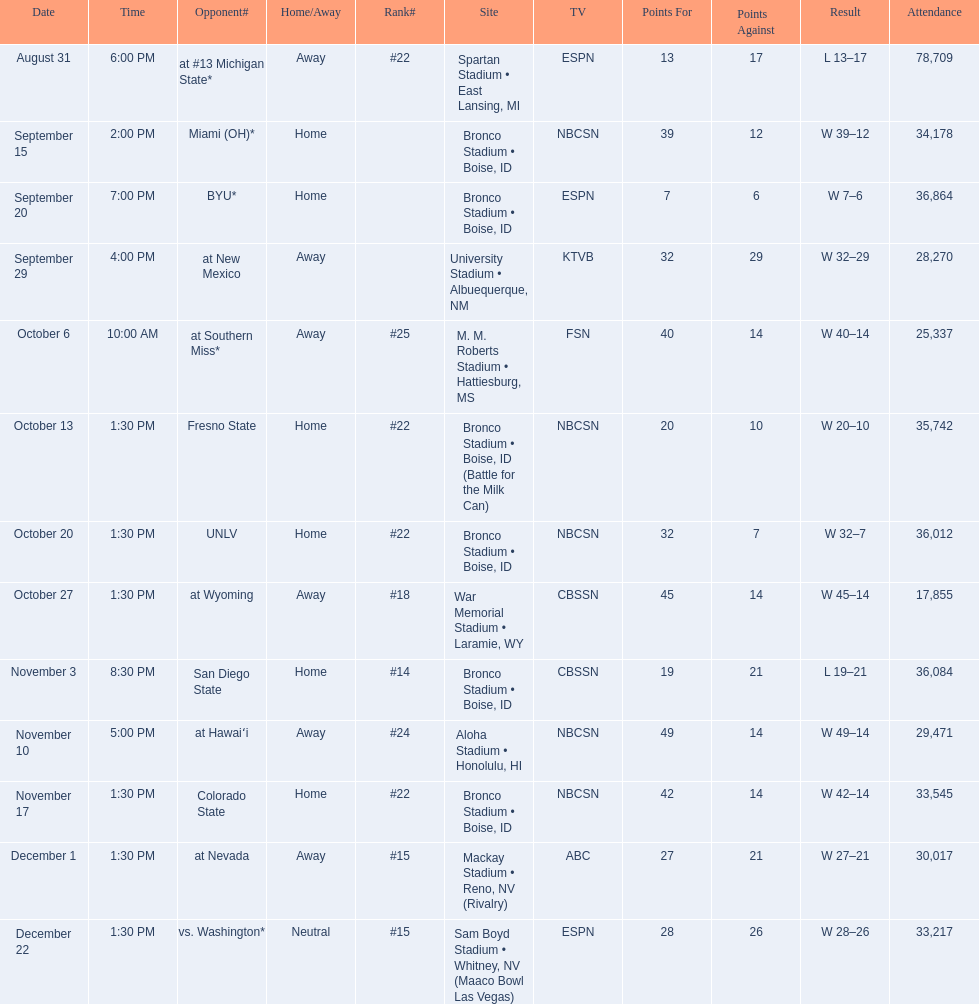What are the opponents to the  2012 boise state broncos football team? At #13 michigan state*, miami (oh)*, byu*, at new mexico, at southern miss*, fresno state, unlv, at wyoming, san diego state, at hawaiʻi, colorado state, at nevada, vs. washington*. Which is the highest ranked of the teams? San Diego State. 